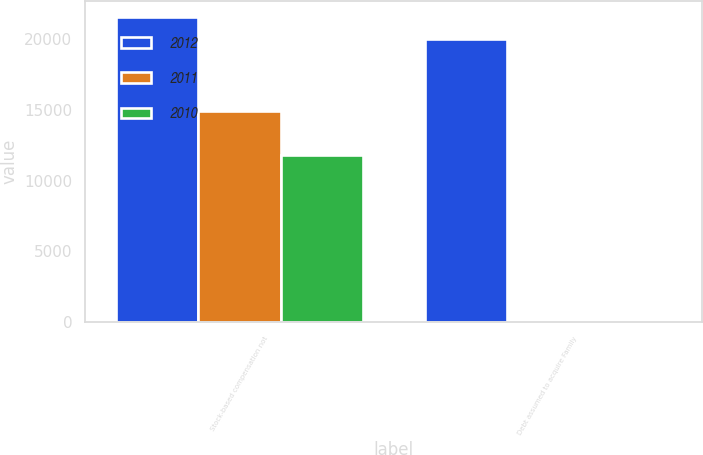Convert chart. <chart><loc_0><loc_0><loc_500><loc_500><stacked_bar_chart><ecel><fcel>Stock-based compensation not<fcel>Debt assumed to acquire Family<nl><fcel>2012<fcel>21605<fcel>20000<nl><fcel>2011<fcel>14954<fcel>0<nl><fcel>2010<fcel>11848<fcel>0<nl></chart> 